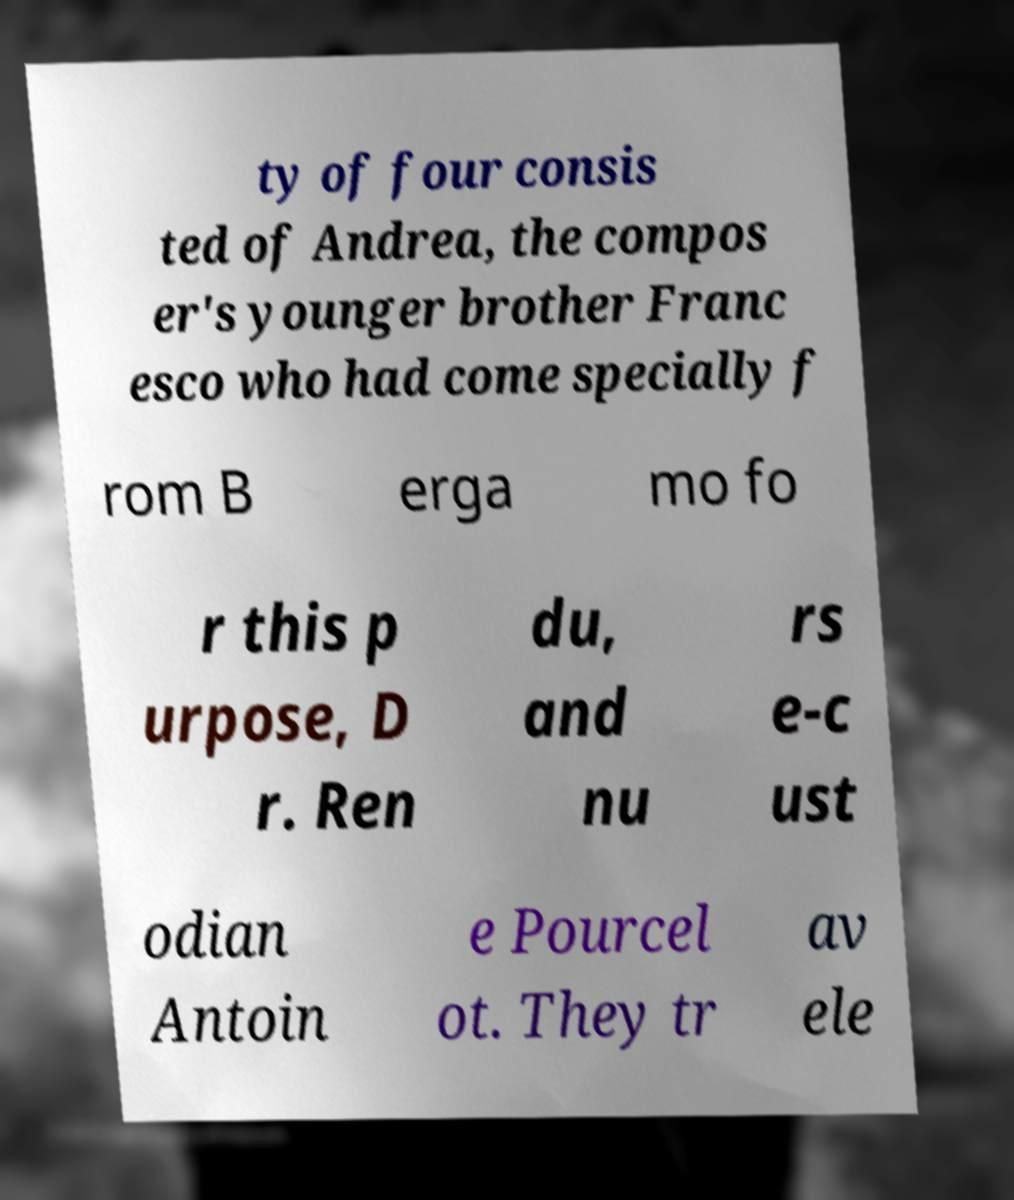Please read and relay the text visible in this image. What does it say? ty of four consis ted of Andrea, the compos er's younger brother Franc esco who had come specially f rom B erga mo fo r this p urpose, D r. Ren du, and nu rs e-c ust odian Antoin e Pourcel ot. They tr av ele 